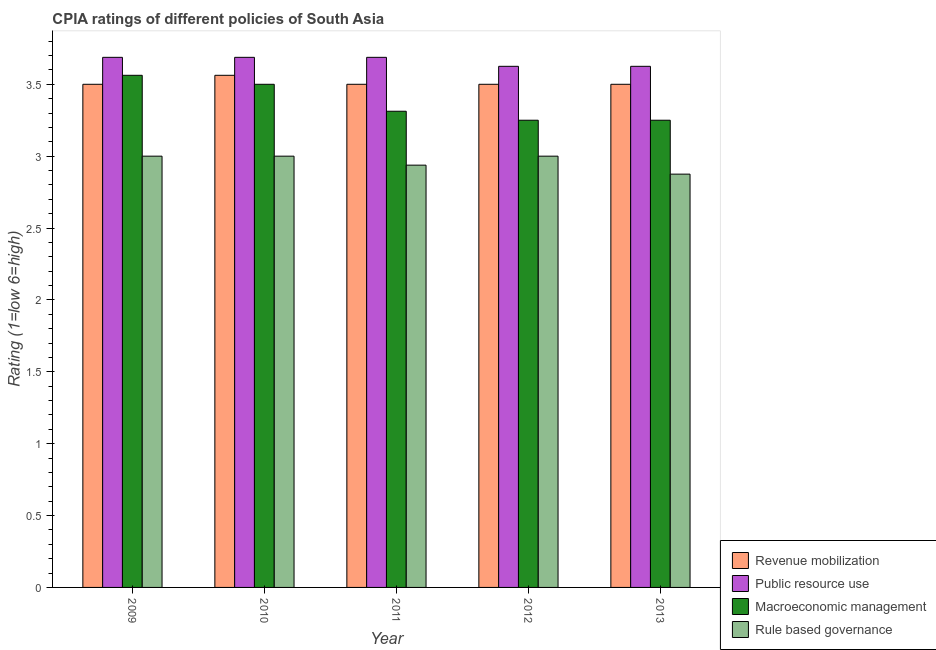How many different coloured bars are there?
Provide a succinct answer. 4. Are the number of bars per tick equal to the number of legend labels?
Offer a terse response. Yes. Are the number of bars on each tick of the X-axis equal?
Make the answer very short. Yes. How many bars are there on the 4th tick from the right?
Your answer should be very brief. 4. In how many cases, is the number of bars for a given year not equal to the number of legend labels?
Your response must be concise. 0. What is the cpia rating of rule based governance in 2010?
Ensure brevity in your answer.  3. Across all years, what is the minimum cpia rating of public resource use?
Your answer should be very brief. 3.62. What is the total cpia rating of macroeconomic management in the graph?
Your answer should be very brief. 16.88. What is the difference between the cpia rating of public resource use in 2010 and the cpia rating of macroeconomic management in 2011?
Provide a succinct answer. 0. What is the average cpia rating of macroeconomic management per year?
Offer a very short reply. 3.38. In the year 2012, what is the difference between the cpia rating of public resource use and cpia rating of macroeconomic management?
Provide a succinct answer. 0. What is the ratio of the cpia rating of revenue mobilization in 2009 to that in 2011?
Keep it short and to the point. 1. Is the difference between the cpia rating of public resource use in 2009 and 2010 greater than the difference between the cpia rating of rule based governance in 2009 and 2010?
Provide a short and direct response. No. What is the difference between the highest and the second highest cpia rating of revenue mobilization?
Offer a terse response. 0.06. What is the difference between the highest and the lowest cpia rating of macroeconomic management?
Make the answer very short. 0.31. What does the 4th bar from the left in 2011 represents?
Keep it short and to the point. Rule based governance. What does the 1st bar from the right in 2011 represents?
Ensure brevity in your answer.  Rule based governance. How many bars are there?
Your answer should be very brief. 20. Does the graph contain grids?
Offer a terse response. No. Where does the legend appear in the graph?
Provide a succinct answer. Bottom right. How many legend labels are there?
Your answer should be very brief. 4. How are the legend labels stacked?
Ensure brevity in your answer.  Vertical. What is the title of the graph?
Offer a terse response. CPIA ratings of different policies of South Asia. Does "Denmark" appear as one of the legend labels in the graph?
Offer a very short reply. No. What is the Rating (1=low 6=high) in Public resource use in 2009?
Provide a succinct answer. 3.69. What is the Rating (1=low 6=high) of Macroeconomic management in 2009?
Offer a very short reply. 3.56. What is the Rating (1=low 6=high) in Revenue mobilization in 2010?
Your response must be concise. 3.56. What is the Rating (1=low 6=high) of Public resource use in 2010?
Keep it short and to the point. 3.69. What is the Rating (1=low 6=high) of Rule based governance in 2010?
Your answer should be very brief. 3. What is the Rating (1=low 6=high) of Revenue mobilization in 2011?
Keep it short and to the point. 3.5. What is the Rating (1=low 6=high) in Public resource use in 2011?
Make the answer very short. 3.69. What is the Rating (1=low 6=high) in Macroeconomic management in 2011?
Offer a terse response. 3.31. What is the Rating (1=low 6=high) of Rule based governance in 2011?
Offer a terse response. 2.94. What is the Rating (1=low 6=high) in Public resource use in 2012?
Offer a very short reply. 3.62. What is the Rating (1=low 6=high) in Rule based governance in 2012?
Offer a very short reply. 3. What is the Rating (1=low 6=high) of Revenue mobilization in 2013?
Offer a very short reply. 3.5. What is the Rating (1=low 6=high) of Public resource use in 2013?
Ensure brevity in your answer.  3.62. What is the Rating (1=low 6=high) of Rule based governance in 2013?
Give a very brief answer. 2.88. Across all years, what is the maximum Rating (1=low 6=high) of Revenue mobilization?
Your answer should be very brief. 3.56. Across all years, what is the maximum Rating (1=low 6=high) in Public resource use?
Provide a short and direct response. 3.69. Across all years, what is the maximum Rating (1=low 6=high) in Macroeconomic management?
Your answer should be compact. 3.56. Across all years, what is the minimum Rating (1=low 6=high) of Revenue mobilization?
Give a very brief answer. 3.5. Across all years, what is the minimum Rating (1=low 6=high) of Public resource use?
Your answer should be compact. 3.62. Across all years, what is the minimum Rating (1=low 6=high) in Rule based governance?
Offer a terse response. 2.88. What is the total Rating (1=low 6=high) in Revenue mobilization in the graph?
Your answer should be compact. 17.56. What is the total Rating (1=low 6=high) of Public resource use in the graph?
Your response must be concise. 18.31. What is the total Rating (1=low 6=high) in Macroeconomic management in the graph?
Offer a very short reply. 16.88. What is the total Rating (1=low 6=high) in Rule based governance in the graph?
Provide a succinct answer. 14.81. What is the difference between the Rating (1=low 6=high) in Revenue mobilization in 2009 and that in 2010?
Your answer should be compact. -0.06. What is the difference between the Rating (1=low 6=high) in Public resource use in 2009 and that in 2010?
Make the answer very short. 0. What is the difference between the Rating (1=low 6=high) of Macroeconomic management in 2009 and that in 2010?
Provide a short and direct response. 0.06. What is the difference between the Rating (1=low 6=high) of Rule based governance in 2009 and that in 2010?
Provide a succinct answer. 0. What is the difference between the Rating (1=low 6=high) in Revenue mobilization in 2009 and that in 2011?
Keep it short and to the point. 0. What is the difference between the Rating (1=low 6=high) of Public resource use in 2009 and that in 2011?
Ensure brevity in your answer.  0. What is the difference between the Rating (1=low 6=high) of Rule based governance in 2009 and that in 2011?
Your answer should be compact. 0.06. What is the difference between the Rating (1=low 6=high) of Public resource use in 2009 and that in 2012?
Keep it short and to the point. 0.06. What is the difference between the Rating (1=low 6=high) of Macroeconomic management in 2009 and that in 2012?
Your answer should be compact. 0.31. What is the difference between the Rating (1=low 6=high) in Revenue mobilization in 2009 and that in 2013?
Ensure brevity in your answer.  0. What is the difference between the Rating (1=low 6=high) in Public resource use in 2009 and that in 2013?
Provide a succinct answer. 0.06. What is the difference between the Rating (1=low 6=high) in Macroeconomic management in 2009 and that in 2013?
Your answer should be compact. 0.31. What is the difference between the Rating (1=low 6=high) of Revenue mobilization in 2010 and that in 2011?
Your response must be concise. 0.06. What is the difference between the Rating (1=low 6=high) of Public resource use in 2010 and that in 2011?
Give a very brief answer. 0. What is the difference between the Rating (1=low 6=high) of Macroeconomic management in 2010 and that in 2011?
Offer a terse response. 0.19. What is the difference between the Rating (1=low 6=high) in Rule based governance in 2010 and that in 2011?
Provide a succinct answer. 0.06. What is the difference between the Rating (1=low 6=high) in Revenue mobilization in 2010 and that in 2012?
Offer a terse response. 0.06. What is the difference between the Rating (1=low 6=high) of Public resource use in 2010 and that in 2012?
Keep it short and to the point. 0.06. What is the difference between the Rating (1=low 6=high) of Rule based governance in 2010 and that in 2012?
Your answer should be very brief. 0. What is the difference between the Rating (1=low 6=high) of Revenue mobilization in 2010 and that in 2013?
Your response must be concise. 0.06. What is the difference between the Rating (1=low 6=high) in Public resource use in 2010 and that in 2013?
Offer a terse response. 0.06. What is the difference between the Rating (1=low 6=high) in Macroeconomic management in 2010 and that in 2013?
Provide a succinct answer. 0.25. What is the difference between the Rating (1=low 6=high) of Revenue mobilization in 2011 and that in 2012?
Provide a succinct answer. 0. What is the difference between the Rating (1=low 6=high) in Public resource use in 2011 and that in 2012?
Offer a terse response. 0.06. What is the difference between the Rating (1=low 6=high) in Macroeconomic management in 2011 and that in 2012?
Offer a terse response. 0.06. What is the difference between the Rating (1=low 6=high) in Rule based governance in 2011 and that in 2012?
Give a very brief answer. -0.06. What is the difference between the Rating (1=low 6=high) of Public resource use in 2011 and that in 2013?
Ensure brevity in your answer.  0.06. What is the difference between the Rating (1=low 6=high) in Macroeconomic management in 2011 and that in 2013?
Your answer should be very brief. 0.06. What is the difference between the Rating (1=low 6=high) in Rule based governance in 2011 and that in 2013?
Ensure brevity in your answer.  0.06. What is the difference between the Rating (1=low 6=high) of Revenue mobilization in 2012 and that in 2013?
Give a very brief answer. 0. What is the difference between the Rating (1=low 6=high) of Revenue mobilization in 2009 and the Rating (1=low 6=high) of Public resource use in 2010?
Make the answer very short. -0.19. What is the difference between the Rating (1=low 6=high) of Public resource use in 2009 and the Rating (1=low 6=high) of Macroeconomic management in 2010?
Provide a short and direct response. 0.19. What is the difference between the Rating (1=low 6=high) in Public resource use in 2009 and the Rating (1=low 6=high) in Rule based governance in 2010?
Give a very brief answer. 0.69. What is the difference between the Rating (1=low 6=high) of Macroeconomic management in 2009 and the Rating (1=low 6=high) of Rule based governance in 2010?
Your response must be concise. 0.56. What is the difference between the Rating (1=low 6=high) of Revenue mobilization in 2009 and the Rating (1=low 6=high) of Public resource use in 2011?
Provide a succinct answer. -0.19. What is the difference between the Rating (1=low 6=high) in Revenue mobilization in 2009 and the Rating (1=low 6=high) in Macroeconomic management in 2011?
Provide a short and direct response. 0.19. What is the difference between the Rating (1=low 6=high) in Revenue mobilization in 2009 and the Rating (1=low 6=high) in Rule based governance in 2011?
Keep it short and to the point. 0.56. What is the difference between the Rating (1=low 6=high) in Public resource use in 2009 and the Rating (1=low 6=high) in Rule based governance in 2011?
Keep it short and to the point. 0.75. What is the difference between the Rating (1=low 6=high) of Revenue mobilization in 2009 and the Rating (1=low 6=high) of Public resource use in 2012?
Make the answer very short. -0.12. What is the difference between the Rating (1=low 6=high) in Public resource use in 2009 and the Rating (1=low 6=high) in Macroeconomic management in 2012?
Your answer should be very brief. 0.44. What is the difference between the Rating (1=low 6=high) in Public resource use in 2009 and the Rating (1=low 6=high) in Rule based governance in 2012?
Your answer should be compact. 0.69. What is the difference between the Rating (1=low 6=high) of Macroeconomic management in 2009 and the Rating (1=low 6=high) of Rule based governance in 2012?
Give a very brief answer. 0.56. What is the difference between the Rating (1=low 6=high) in Revenue mobilization in 2009 and the Rating (1=low 6=high) in Public resource use in 2013?
Your response must be concise. -0.12. What is the difference between the Rating (1=low 6=high) of Revenue mobilization in 2009 and the Rating (1=low 6=high) of Macroeconomic management in 2013?
Your answer should be very brief. 0.25. What is the difference between the Rating (1=low 6=high) in Public resource use in 2009 and the Rating (1=low 6=high) in Macroeconomic management in 2013?
Ensure brevity in your answer.  0.44. What is the difference between the Rating (1=low 6=high) of Public resource use in 2009 and the Rating (1=low 6=high) of Rule based governance in 2013?
Ensure brevity in your answer.  0.81. What is the difference between the Rating (1=low 6=high) of Macroeconomic management in 2009 and the Rating (1=low 6=high) of Rule based governance in 2013?
Make the answer very short. 0.69. What is the difference between the Rating (1=low 6=high) in Revenue mobilization in 2010 and the Rating (1=low 6=high) in Public resource use in 2011?
Make the answer very short. -0.12. What is the difference between the Rating (1=low 6=high) of Public resource use in 2010 and the Rating (1=low 6=high) of Macroeconomic management in 2011?
Provide a succinct answer. 0.38. What is the difference between the Rating (1=low 6=high) in Public resource use in 2010 and the Rating (1=low 6=high) in Rule based governance in 2011?
Your response must be concise. 0.75. What is the difference between the Rating (1=low 6=high) in Macroeconomic management in 2010 and the Rating (1=low 6=high) in Rule based governance in 2011?
Make the answer very short. 0.56. What is the difference between the Rating (1=low 6=high) in Revenue mobilization in 2010 and the Rating (1=low 6=high) in Public resource use in 2012?
Your answer should be compact. -0.06. What is the difference between the Rating (1=low 6=high) of Revenue mobilization in 2010 and the Rating (1=low 6=high) of Macroeconomic management in 2012?
Your answer should be compact. 0.31. What is the difference between the Rating (1=low 6=high) in Revenue mobilization in 2010 and the Rating (1=low 6=high) in Rule based governance in 2012?
Ensure brevity in your answer.  0.56. What is the difference between the Rating (1=low 6=high) of Public resource use in 2010 and the Rating (1=low 6=high) of Macroeconomic management in 2012?
Offer a terse response. 0.44. What is the difference between the Rating (1=low 6=high) in Public resource use in 2010 and the Rating (1=low 6=high) in Rule based governance in 2012?
Give a very brief answer. 0.69. What is the difference between the Rating (1=low 6=high) of Macroeconomic management in 2010 and the Rating (1=low 6=high) of Rule based governance in 2012?
Your answer should be very brief. 0.5. What is the difference between the Rating (1=low 6=high) in Revenue mobilization in 2010 and the Rating (1=low 6=high) in Public resource use in 2013?
Give a very brief answer. -0.06. What is the difference between the Rating (1=low 6=high) in Revenue mobilization in 2010 and the Rating (1=low 6=high) in Macroeconomic management in 2013?
Make the answer very short. 0.31. What is the difference between the Rating (1=low 6=high) of Revenue mobilization in 2010 and the Rating (1=low 6=high) of Rule based governance in 2013?
Keep it short and to the point. 0.69. What is the difference between the Rating (1=low 6=high) in Public resource use in 2010 and the Rating (1=low 6=high) in Macroeconomic management in 2013?
Keep it short and to the point. 0.44. What is the difference between the Rating (1=low 6=high) in Public resource use in 2010 and the Rating (1=low 6=high) in Rule based governance in 2013?
Offer a terse response. 0.81. What is the difference between the Rating (1=low 6=high) in Macroeconomic management in 2010 and the Rating (1=low 6=high) in Rule based governance in 2013?
Provide a succinct answer. 0.62. What is the difference between the Rating (1=low 6=high) of Revenue mobilization in 2011 and the Rating (1=low 6=high) of Public resource use in 2012?
Offer a terse response. -0.12. What is the difference between the Rating (1=low 6=high) of Revenue mobilization in 2011 and the Rating (1=low 6=high) of Macroeconomic management in 2012?
Your answer should be very brief. 0.25. What is the difference between the Rating (1=low 6=high) of Public resource use in 2011 and the Rating (1=low 6=high) of Macroeconomic management in 2012?
Provide a short and direct response. 0.44. What is the difference between the Rating (1=low 6=high) in Public resource use in 2011 and the Rating (1=low 6=high) in Rule based governance in 2012?
Offer a terse response. 0.69. What is the difference between the Rating (1=low 6=high) of Macroeconomic management in 2011 and the Rating (1=low 6=high) of Rule based governance in 2012?
Keep it short and to the point. 0.31. What is the difference between the Rating (1=low 6=high) in Revenue mobilization in 2011 and the Rating (1=low 6=high) in Public resource use in 2013?
Offer a very short reply. -0.12. What is the difference between the Rating (1=low 6=high) in Revenue mobilization in 2011 and the Rating (1=low 6=high) in Rule based governance in 2013?
Your answer should be very brief. 0.62. What is the difference between the Rating (1=low 6=high) of Public resource use in 2011 and the Rating (1=low 6=high) of Macroeconomic management in 2013?
Offer a terse response. 0.44. What is the difference between the Rating (1=low 6=high) of Public resource use in 2011 and the Rating (1=low 6=high) of Rule based governance in 2013?
Offer a very short reply. 0.81. What is the difference between the Rating (1=low 6=high) in Macroeconomic management in 2011 and the Rating (1=low 6=high) in Rule based governance in 2013?
Offer a terse response. 0.44. What is the difference between the Rating (1=low 6=high) of Revenue mobilization in 2012 and the Rating (1=low 6=high) of Public resource use in 2013?
Ensure brevity in your answer.  -0.12. What is the difference between the Rating (1=low 6=high) in Public resource use in 2012 and the Rating (1=low 6=high) in Rule based governance in 2013?
Ensure brevity in your answer.  0.75. What is the difference between the Rating (1=low 6=high) in Macroeconomic management in 2012 and the Rating (1=low 6=high) in Rule based governance in 2013?
Provide a short and direct response. 0.38. What is the average Rating (1=low 6=high) in Revenue mobilization per year?
Your answer should be compact. 3.51. What is the average Rating (1=low 6=high) in Public resource use per year?
Your answer should be compact. 3.66. What is the average Rating (1=low 6=high) of Macroeconomic management per year?
Your answer should be compact. 3.38. What is the average Rating (1=low 6=high) of Rule based governance per year?
Offer a very short reply. 2.96. In the year 2009, what is the difference between the Rating (1=low 6=high) of Revenue mobilization and Rating (1=low 6=high) of Public resource use?
Your answer should be very brief. -0.19. In the year 2009, what is the difference between the Rating (1=low 6=high) in Revenue mobilization and Rating (1=low 6=high) in Macroeconomic management?
Your answer should be very brief. -0.06. In the year 2009, what is the difference between the Rating (1=low 6=high) in Public resource use and Rating (1=low 6=high) in Rule based governance?
Make the answer very short. 0.69. In the year 2009, what is the difference between the Rating (1=low 6=high) of Macroeconomic management and Rating (1=low 6=high) of Rule based governance?
Give a very brief answer. 0.56. In the year 2010, what is the difference between the Rating (1=low 6=high) of Revenue mobilization and Rating (1=low 6=high) of Public resource use?
Offer a terse response. -0.12. In the year 2010, what is the difference between the Rating (1=low 6=high) in Revenue mobilization and Rating (1=low 6=high) in Macroeconomic management?
Offer a very short reply. 0.06. In the year 2010, what is the difference between the Rating (1=low 6=high) in Revenue mobilization and Rating (1=low 6=high) in Rule based governance?
Provide a short and direct response. 0.56. In the year 2010, what is the difference between the Rating (1=low 6=high) in Public resource use and Rating (1=low 6=high) in Macroeconomic management?
Make the answer very short. 0.19. In the year 2010, what is the difference between the Rating (1=low 6=high) of Public resource use and Rating (1=low 6=high) of Rule based governance?
Your answer should be very brief. 0.69. In the year 2010, what is the difference between the Rating (1=low 6=high) in Macroeconomic management and Rating (1=low 6=high) in Rule based governance?
Your answer should be very brief. 0.5. In the year 2011, what is the difference between the Rating (1=low 6=high) in Revenue mobilization and Rating (1=low 6=high) in Public resource use?
Your answer should be compact. -0.19. In the year 2011, what is the difference between the Rating (1=low 6=high) of Revenue mobilization and Rating (1=low 6=high) of Macroeconomic management?
Keep it short and to the point. 0.19. In the year 2011, what is the difference between the Rating (1=low 6=high) in Revenue mobilization and Rating (1=low 6=high) in Rule based governance?
Ensure brevity in your answer.  0.56. In the year 2011, what is the difference between the Rating (1=low 6=high) in Macroeconomic management and Rating (1=low 6=high) in Rule based governance?
Offer a very short reply. 0.38. In the year 2012, what is the difference between the Rating (1=low 6=high) in Revenue mobilization and Rating (1=low 6=high) in Public resource use?
Your response must be concise. -0.12. In the year 2012, what is the difference between the Rating (1=low 6=high) in Revenue mobilization and Rating (1=low 6=high) in Rule based governance?
Your answer should be very brief. 0.5. In the year 2012, what is the difference between the Rating (1=low 6=high) of Public resource use and Rating (1=low 6=high) of Rule based governance?
Your response must be concise. 0.62. In the year 2013, what is the difference between the Rating (1=low 6=high) of Revenue mobilization and Rating (1=low 6=high) of Public resource use?
Give a very brief answer. -0.12. In the year 2013, what is the difference between the Rating (1=low 6=high) of Revenue mobilization and Rating (1=low 6=high) of Macroeconomic management?
Provide a succinct answer. 0.25. In the year 2013, what is the difference between the Rating (1=low 6=high) in Public resource use and Rating (1=low 6=high) in Macroeconomic management?
Keep it short and to the point. 0.38. In the year 2013, what is the difference between the Rating (1=low 6=high) of Public resource use and Rating (1=low 6=high) of Rule based governance?
Your answer should be very brief. 0.75. In the year 2013, what is the difference between the Rating (1=low 6=high) of Macroeconomic management and Rating (1=low 6=high) of Rule based governance?
Give a very brief answer. 0.38. What is the ratio of the Rating (1=low 6=high) in Revenue mobilization in 2009 to that in 2010?
Your answer should be very brief. 0.98. What is the ratio of the Rating (1=low 6=high) in Macroeconomic management in 2009 to that in 2010?
Make the answer very short. 1.02. What is the ratio of the Rating (1=low 6=high) in Rule based governance in 2009 to that in 2010?
Your answer should be compact. 1. What is the ratio of the Rating (1=low 6=high) in Macroeconomic management in 2009 to that in 2011?
Offer a terse response. 1.08. What is the ratio of the Rating (1=low 6=high) in Rule based governance in 2009 to that in 2011?
Your response must be concise. 1.02. What is the ratio of the Rating (1=low 6=high) in Revenue mobilization in 2009 to that in 2012?
Your answer should be compact. 1. What is the ratio of the Rating (1=low 6=high) of Public resource use in 2009 to that in 2012?
Make the answer very short. 1.02. What is the ratio of the Rating (1=low 6=high) of Macroeconomic management in 2009 to that in 2012?
Your response must be concise. 1.1. What is the ratio of the Rating (1=low 6=high) of Public resource use in 2009 to that in 2013?
Provide a succinct answer. 1.02. What is the ratio of the Rating (1=low 6=high) of Macroeconomic management in 2009 to that in 2013?
Your answer should be compact. 1.1. What is the ratio of the Rating (1=low 6=high) in Rule based governance in 2009 to that in 2013?
Give a very brief answer. 1.04. What is the ratio of the Rating (1=low 6=high) of Revenue mobilization in 2010 to that in 2011?
Give a very brief answer. 1.02. What is the ratio of the Rating (1=low 6=high) of Public resource use in 2010 to that in 2011?
Make the answer very short. 1. What is the ratio of the Rating (1=low 6=high) of Macroeconomic management in 2010 to that in 2011?
Your answer should be compact. 1.06. What is the ratio of the Rating (1=low 6=high) of Rule based governance in 2010 to that in 2011?
Provide a succinct answer. 1.02. What is the ratio of the Rating (1=low 6=high) of Revenue mobilization in 2010 to that in 2012?
Give a very brief answer. 1.02. What is the ratio of the Rating (1=low 6=high) in Public resource use in 2010 to that in 2012?
Keep it short and to the point. 1.02. What is the ratio of the Rating (1=low 6=high) of Macroeconomic management in 2010 to that in 2012?
Your response must be concise. 1.08. What is the ratio of the Rating (1=low 6=high) of Rule based governance in 2010 to that in 2012?
Give a very brief answer. 1. What is the ratio of the Rating (1=low 6=high) in Revenue mobilization in 2010 to that in 2013?
Ensure brevity in your answer.  1.02. What is the ratio of the Rating (1=low 6=high) of Public resource use in 2010 to that in 2013?
Make the answer very short. 1.02. What is the ratio of the Rating (1=low 6=high) in Rule based governance in 2010 to that in 2013?
Your response must be concise. 1.04. What is the ratio of the Rating (1=low 6=high) in Public resource use in 2011 to that in 2012?
Your answer should be very brief. 1.02. What is the ratio of the Rating (1=low 6=high) in Macroeconomic management in 2011 to that in 2012?
Your response must be concise. 1.02. What is the ratio of the Rating (1=low 6=high) in Rule based governance in 2011 to that in 2012?
Provide a short and direct response. 0.98. What is the ratio of the Rating (1=low 6=high) of Public resource use in 2011 to that in 2013?
Keep it short and to the point. 1.02. What is the ratio of the Rating (1=low 6=high) of Macroeconomic management in 2011 to that in 2013?
Your response must be concise. 1.02. What is the ratio of the Rating (1=low 6=high) of Rule based governance in 2011 to that in 2013?
Your response must be concise. 1.02. What is the ratio of the Rating (1=low 6=high) in Revenue mobilization in 2012 to that in 2013?
Give a very brief answer. 1. What is the ratio of the Rating (1=low 6=high) in Public resource use in 2012 to that in 2013?
Keep it short and to the point. 1. What is the ratio of the Rating (1=low 6=high) of Macroeconomic management in 2012 to that in 2013?
Provide a succinct answer. 1. What is the ratio of the Rating (1=low 6=high) of Rule based governance in 2012 to that in 2013?
Your response must be concise. 1.04. What is the difference between the highest and the second highest Rating (1=low 6=high) of Revenue mobilization?
Your answer should be compact. 0.06. What is the difference between the highest and the second highest Rating (1=low 6=high) of Macroeconomic management?
Your answer should be compact. 0.06. What is the difference between the highest and the second highest Rating (1=low 6=high) of Rule based governance?
Give a very brief answer. 0. What is the difference between the highest and the lowest Rating (1=low 6=high) of Revenue mobilization?
Your answer should be compact. 0.06. What is the difference between the highest and the lowest Rating (1=low 6=high) in Public resource use?
Keep it short and to the point. 0.06. What is the difference between the highest and the lowest Rating (1=low 6=high) of Macroeconomic management?
Your response must be concise. 0.31. What is the difference between the highest and the lowest Rating (1=low 6=high) of Rule based governance?
Make the answer very short. 0.12. 